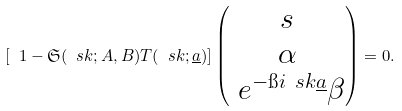<formula> <loc_0><loc_0><loc_500><loc_500>\left [ \ 1 - \mathfrak { S } ( \ s k ; A , B ) T ( \ s k ; \underline { a } ) \right ] \begin{pmatrix} s \\ \alpha \\ \ e ^ { - \i i \ s k \underline { a } } \beta \end{pmatrix} = 0 .</formula> 